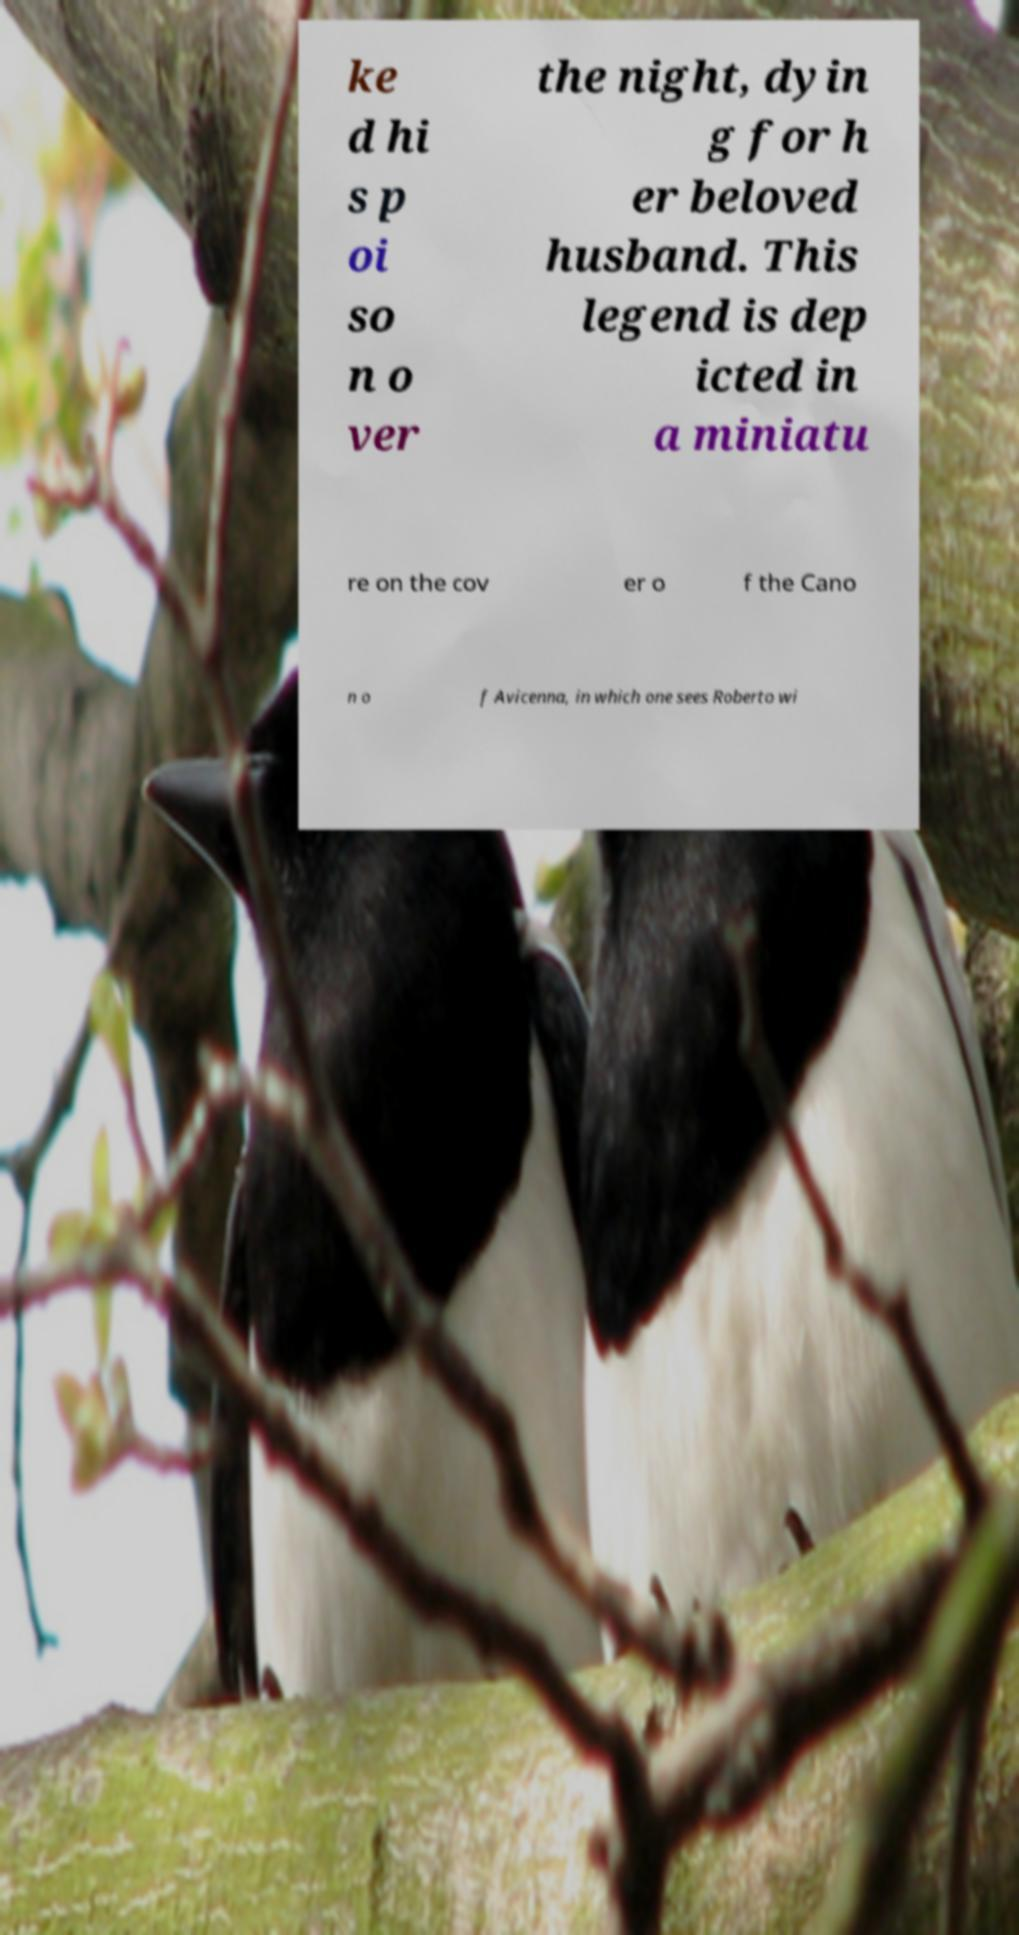What messages or text are displayed in this image? I need them in a readable, typed format. ke d hi s p oi so n o ver the night, dyin g for h er beloved husband. This legend is dep icted in a miniatu re on the cov er o f the Cano n o f Avicenna, in which one sees Roberto wi 